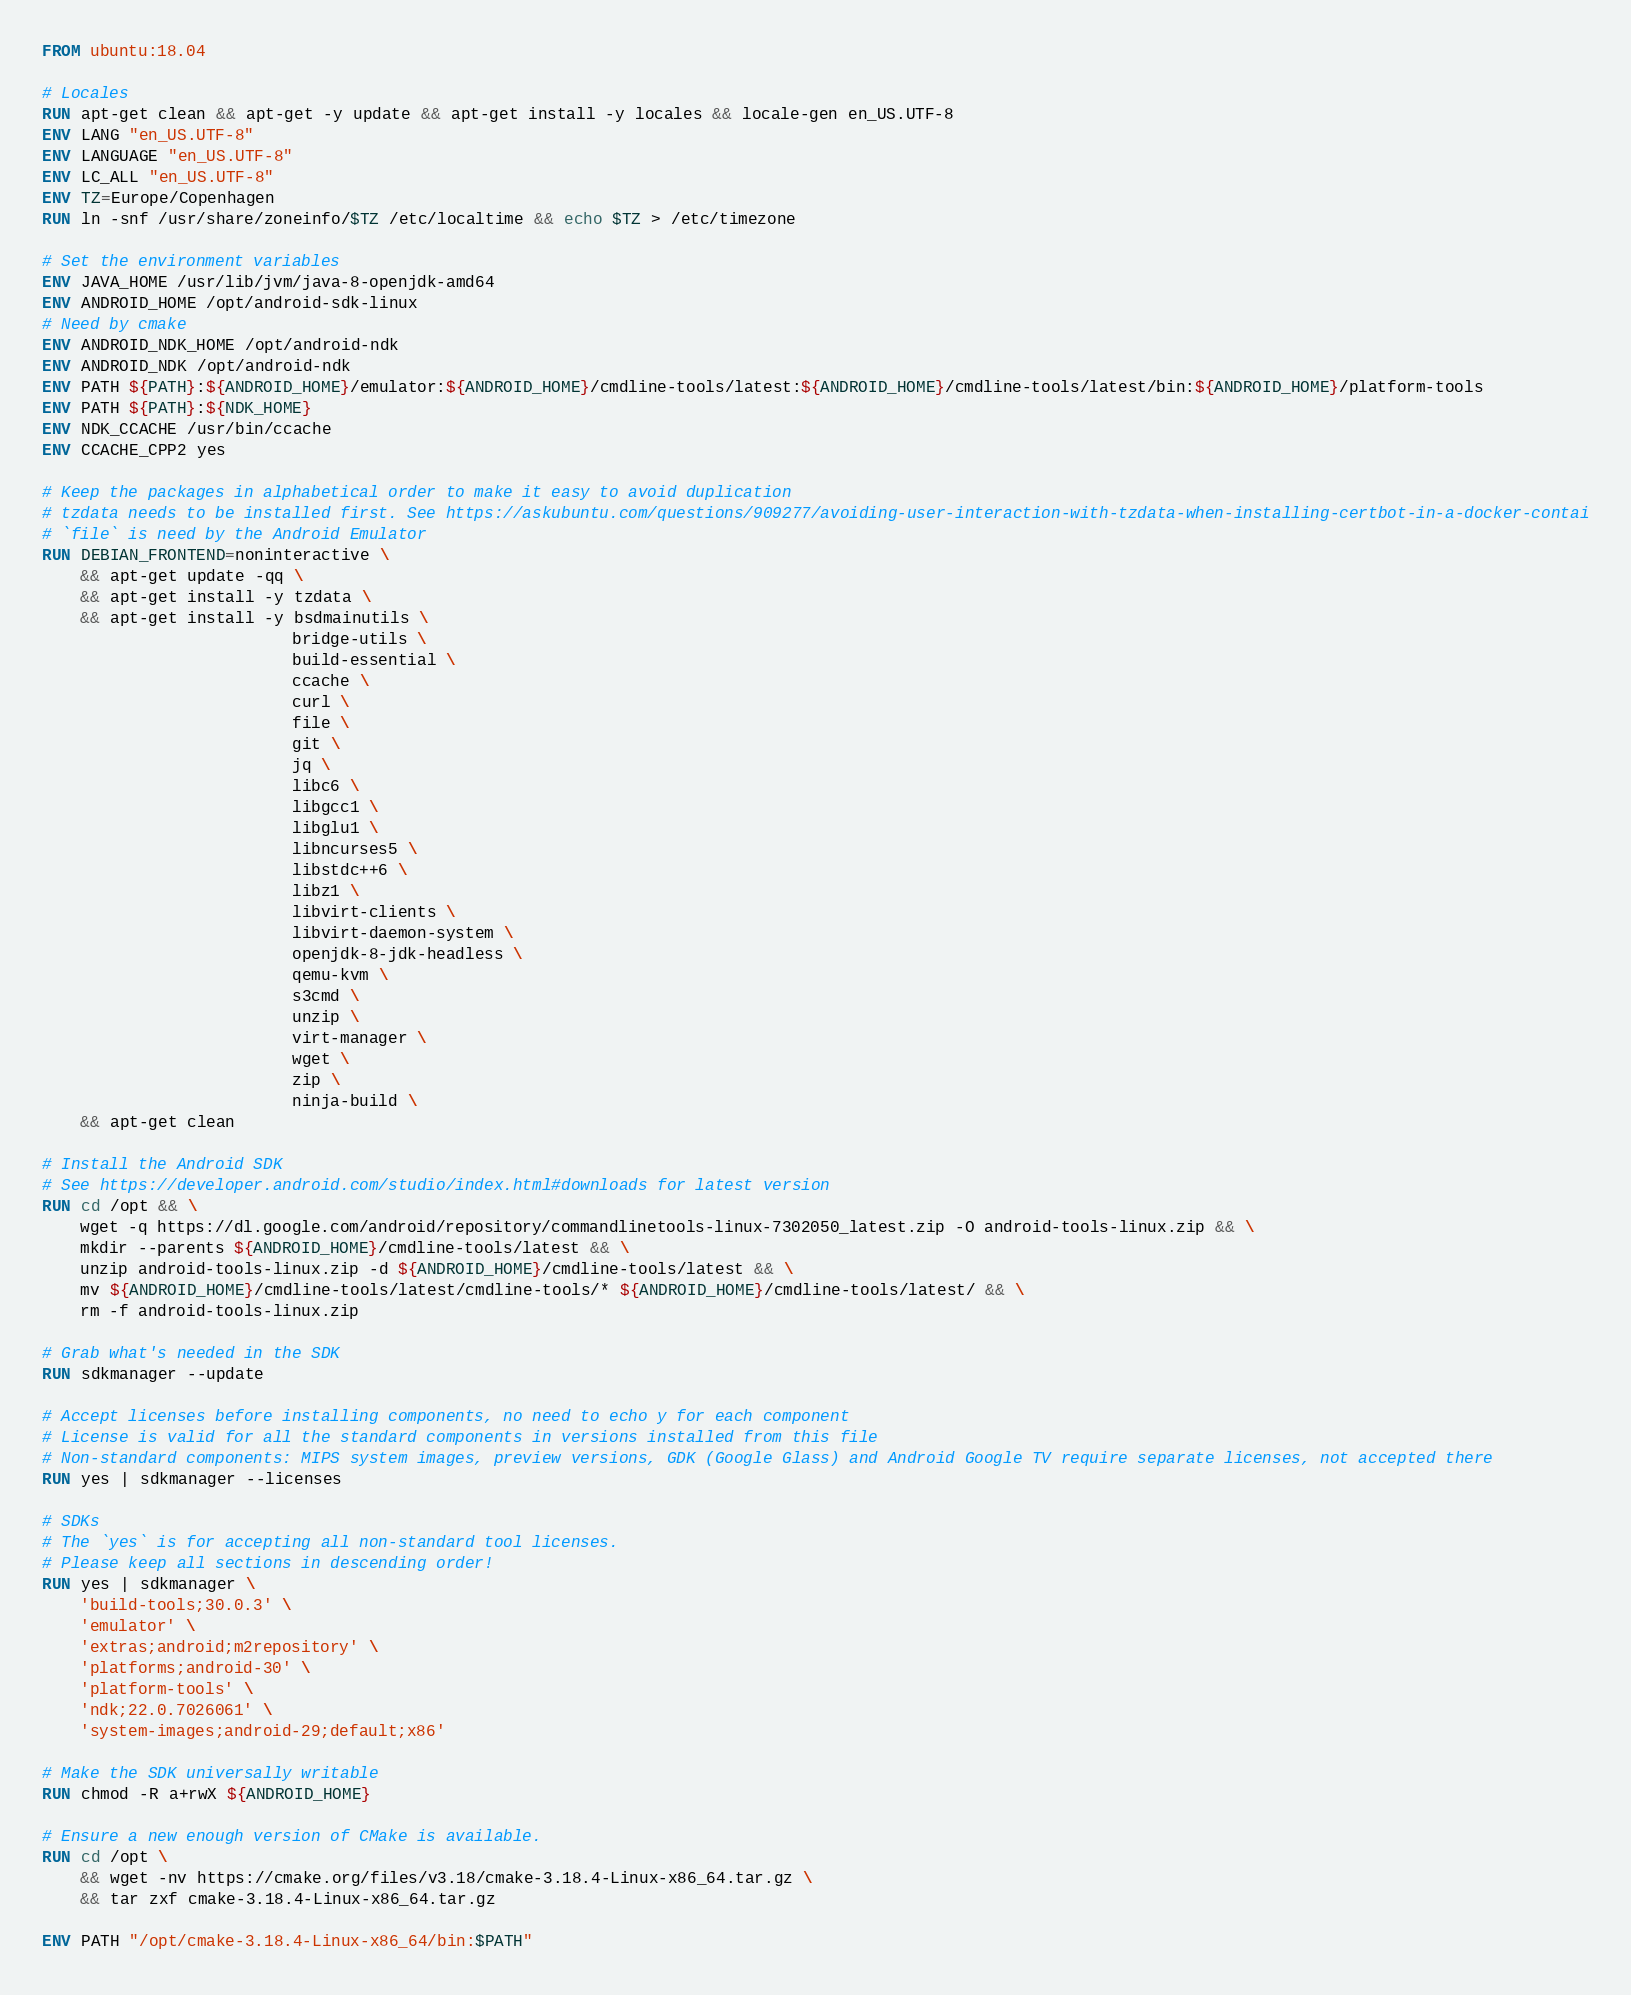<code> <loc_0><loc_0><loc_500><loc_500><_Dockerfile_>FROM ubuntu:18.04

# Locales
RUN apt-get clean && apt-get -y update && apt-get install -y locales && locale-gen en_US.UTF-8
ENV LANG "en_US.UTF-8"
ENV LANGUAGE "en_US.UTF-8"
ENV LC_ALL "en_US.UTF-8"
ENV TZ=Europe/Copenhagen
RUN ln -snf /usr/share/zoneinfo/$TZ /etc/localtime && echo $TZ > /etc/timezone

# Set the environment variables
ENV JAVA_HOME /usr/lib/jvm/java-8-openjdk-amd64
ENV ANDROID_HOME /opt/android-sdk-linux
# Need by cmake
ENV ANDROID_NDK_HOME /opt/android-ndk
ENV ANDROID_NDK /opt/android-ndk
ENV PATH ${PATH}:${ANDROID_HOME}/emulator:${ANDROID_HOME}/cmdline-tools/latest:${ANDROID_HOME}/cmdline-tools/latest/bin:${ANDROID_HOME}/platform-tools
ENV PATH ${PATH}:${NDK_HOME}
ENV NDK_CCACHE /usr/bin/ccache
ENV CCACHE_CPP2 yes

# Keep the packages in alphabetical order to make it easy to avoid duplication
# tzdata needs to be installed first. See https://askubuntu.com/questions/909277/avoiding-user-interaction-with-tzdata-when-installing-certbot-in-a-docker-contai
# `file` is need by the Android Emulator
RUN DEBIAN_FRONTEND=noninteractive \
    && apt-get update -qq \
    && apt-get install -y tzdata \
    && apt-get install -y bsdmainutils \
                          bridge-utils \
                          build-essential \
                          ccache \
                          curl \
                          file \
                          git \
                          jq \
                          libc6 \
                          libgcc1 \
                          libglu1 \
                          libncurses5 \
                          libstdc++6 \
                          libz1 \
                          libvirt-clients \
                          libvirt-daemon-system \
                          openjdk-8-jdk-headless \
                          qemu-kvm \
                          s3cmd \
                          unzip \
                          virt-manager \
                          wget \
                          zip \
                          ninja-build \
    && apt-get clean

# Install the Android SDK
# See https://developer.android.com/studio/index.html#downloads for latest version
RUN cd /opt && \
    wget -q https://dl.google.com/android/repository/commandlinetools-linux-7302050_latest.zip -O android-tools-linux.zip && \
    mkdir --parents ${ANDROID_HOME}/cmdline-tools/latest && \
    unzip android-tools-linux.zip -d ${ANDROID_HOME}/cmdline-tools/latest && \
    mv ${ANDROID_HOME}/cmdline-tools/latest/cmdline-tools/* ${ANDROID_HOME}/cmdline-tools/latest/ && \
    rm -f android-tools-linux.zip

# Grab what's needed in the SDK
RUN sdkmanager --update

# Accept licenses before installing components, no need to echo y for each component
# License is valid for all the standard components in versions installed from this file
# Non-standard components: MIPS system images, preview versions, GDK (Google Glass) and Android Google TV require separate licenses, not accepted there
RUN yes | sdkmanager --licenses

# SDKs
# The `yes` is for accepting all non-standard tool licenses.
# Please keep all sections in descending order!
RUN yes | sdkmanager \
    'build-tools;30.0.3' \
    'emulator' \
    'extras;android;m2repository' \
    'platforms;android-30' \
    'platform-tools' \
    'ndk;22.0.7026061' \
    'system-images;android-29;default;x86'

# Make the SDK universally writable
RUN chmod -R a+rwX ${ANDROID_HOME}

# Ensure a new enough version of CMake is available.
RUN cd /opt \
    && wget -nv https://cmake.org/files/v3.18/cmake-3.18.4-Linux-x86_64.tar.gz \
    && tar zxf cmake-3.18.4-Linux-x86_64.tar.gz

ENV PATH "/opt/cmake-3.18.4-Linux-x86_64/bin:$PATH"
</code> 